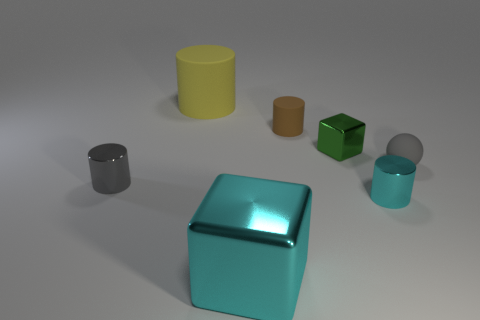There is a block behind the sphere; are there any brown matte objects that are to the right of it?
Give a very brief answer. No. What number of other objects are there of the same shape as the big matte thing?
Ensure brevity in your answer.  3. Does the yellow rubber object have the same shape as the big cyan thing?
Make the answer very short. No. The small thing that is on the left side of the green shiny cube and in front of the green shiny cube is what color?
Offer a terse response. Gray. The metallic cylinder that is the same color as the small rubber sphere is what size?
Your response must be concise. Small. What number of big things are either brown matte blocks or gray metal objects?
Offer a very short reply. 0. Is there anything else that has the same color as the big matte object?
Your answer should be very brief. No. What is the material of the small cylinder right of the cube behind the small thing in front of the small gray cylinder?
Give a very brief answer. Metal. How many rubber objects are either green spheres or large cyan things?
Provide a short and direct response. 0. What number of cyan objects are metallic cylinders or shiny cubes?
Offer a terse response. 2. 